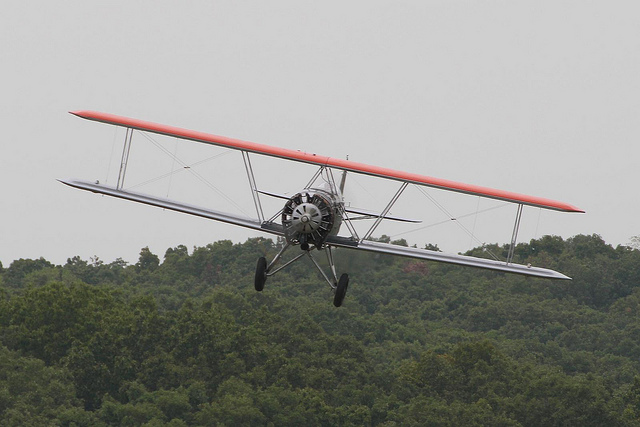Could you mention any famous pilots who may have flown this kind of airplane? One of the most famous pilots associated with biplanes like this one was Manfred von Richthofen, also known as the Red Baron, who was a notable fighter pilot during World War I. Other notable pilots include Amelia Earhart, who also flew biplanes early in her aviation career before moving on to more advanced aircraft. 